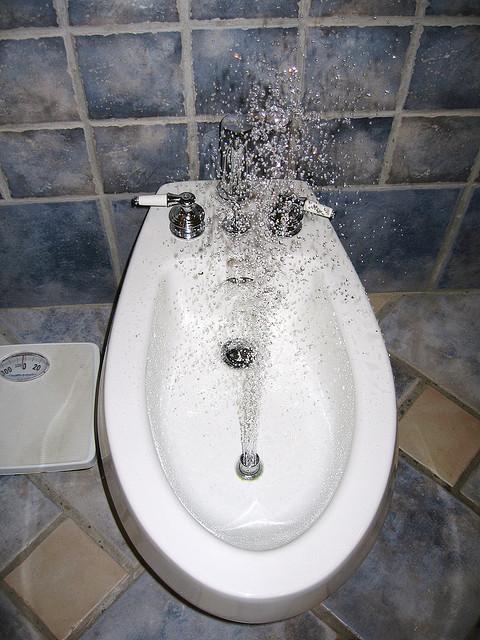Which side of the toilet tells your weight?
Quick response, please. Left. What is coming out of the toilet?
Give a very brief answer. Water. What color is the scale?
Give a very brief answer. White. 